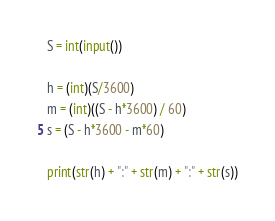Convert code to text. <code><loc_0><loc_0><loc_500><loc_500><_Python_>S = int(input())

h = (int)(S/3600)
m = (int)((S - h*3600) / 60)
s = (S - h*3600 - m*60)

print(str(h) + ":" + str(m) + ":" + str(s))
</code> 